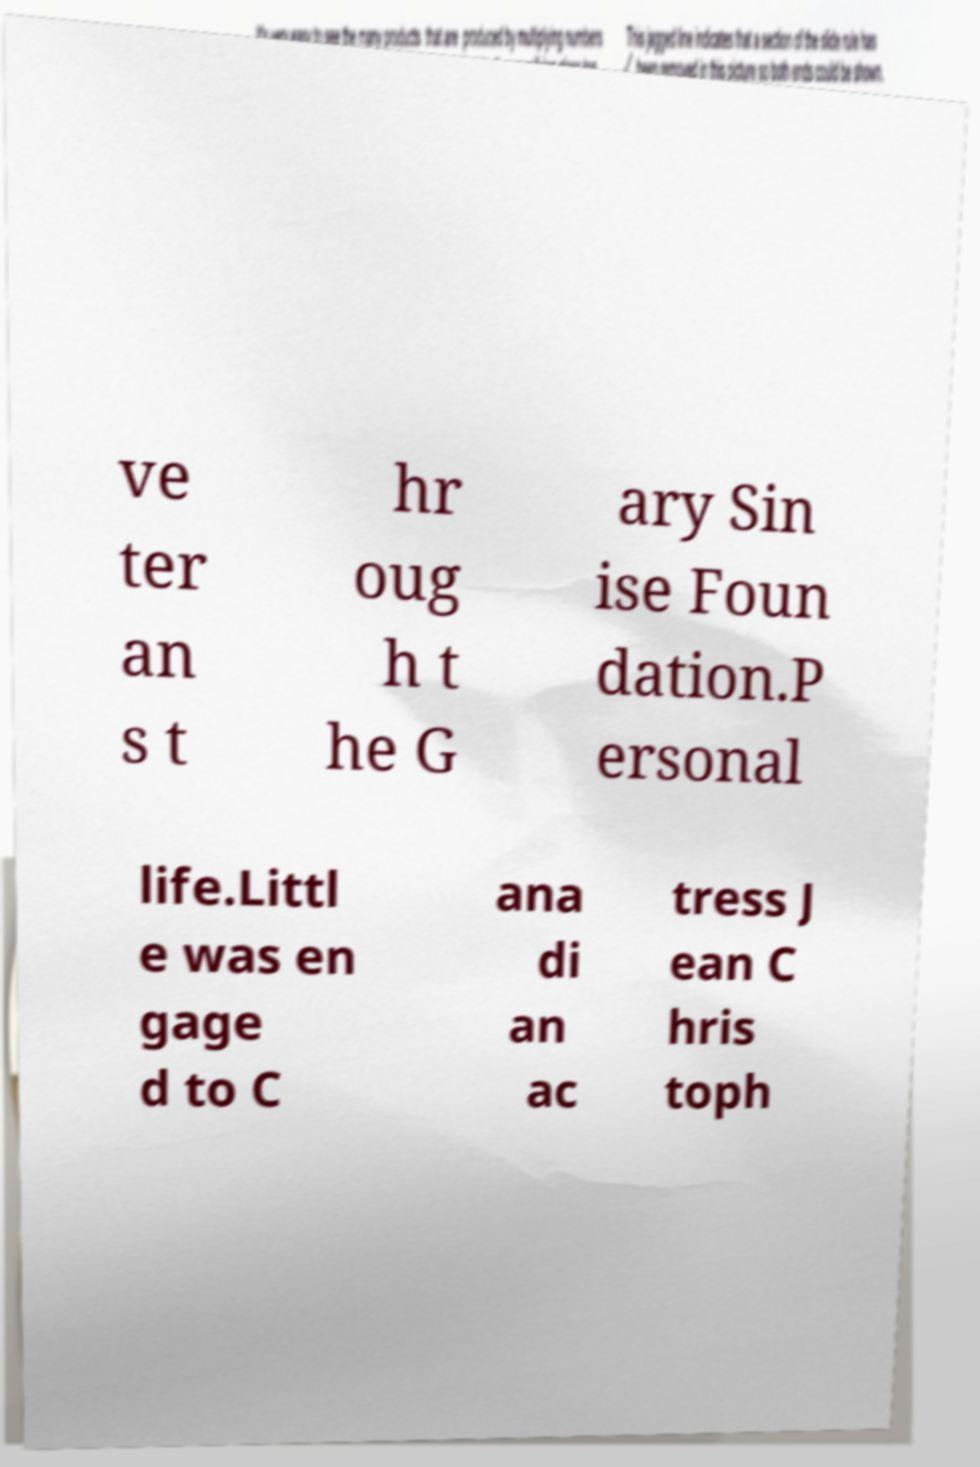Could you extract and type out the text from this image? ve ter an s t hr oug h t he G ary Sin ise Foun dation.P ersonal life.Littl e was en gage d to C ana di an ac tress J ean C hris toph 